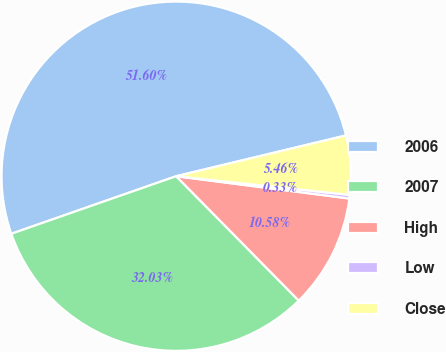Convert chart to OTSL. <chart><loc_0><loc_0><loc_500><loc_500><pie_chart><fcel>2006<fcel>2007<fcel>High<fcel>Low<fcel>Close<nl><fcel>51.59%<fcel>32.03%<fcel>10.58%<fcel>0.33%<fcel>5.46%<nl></chart> 